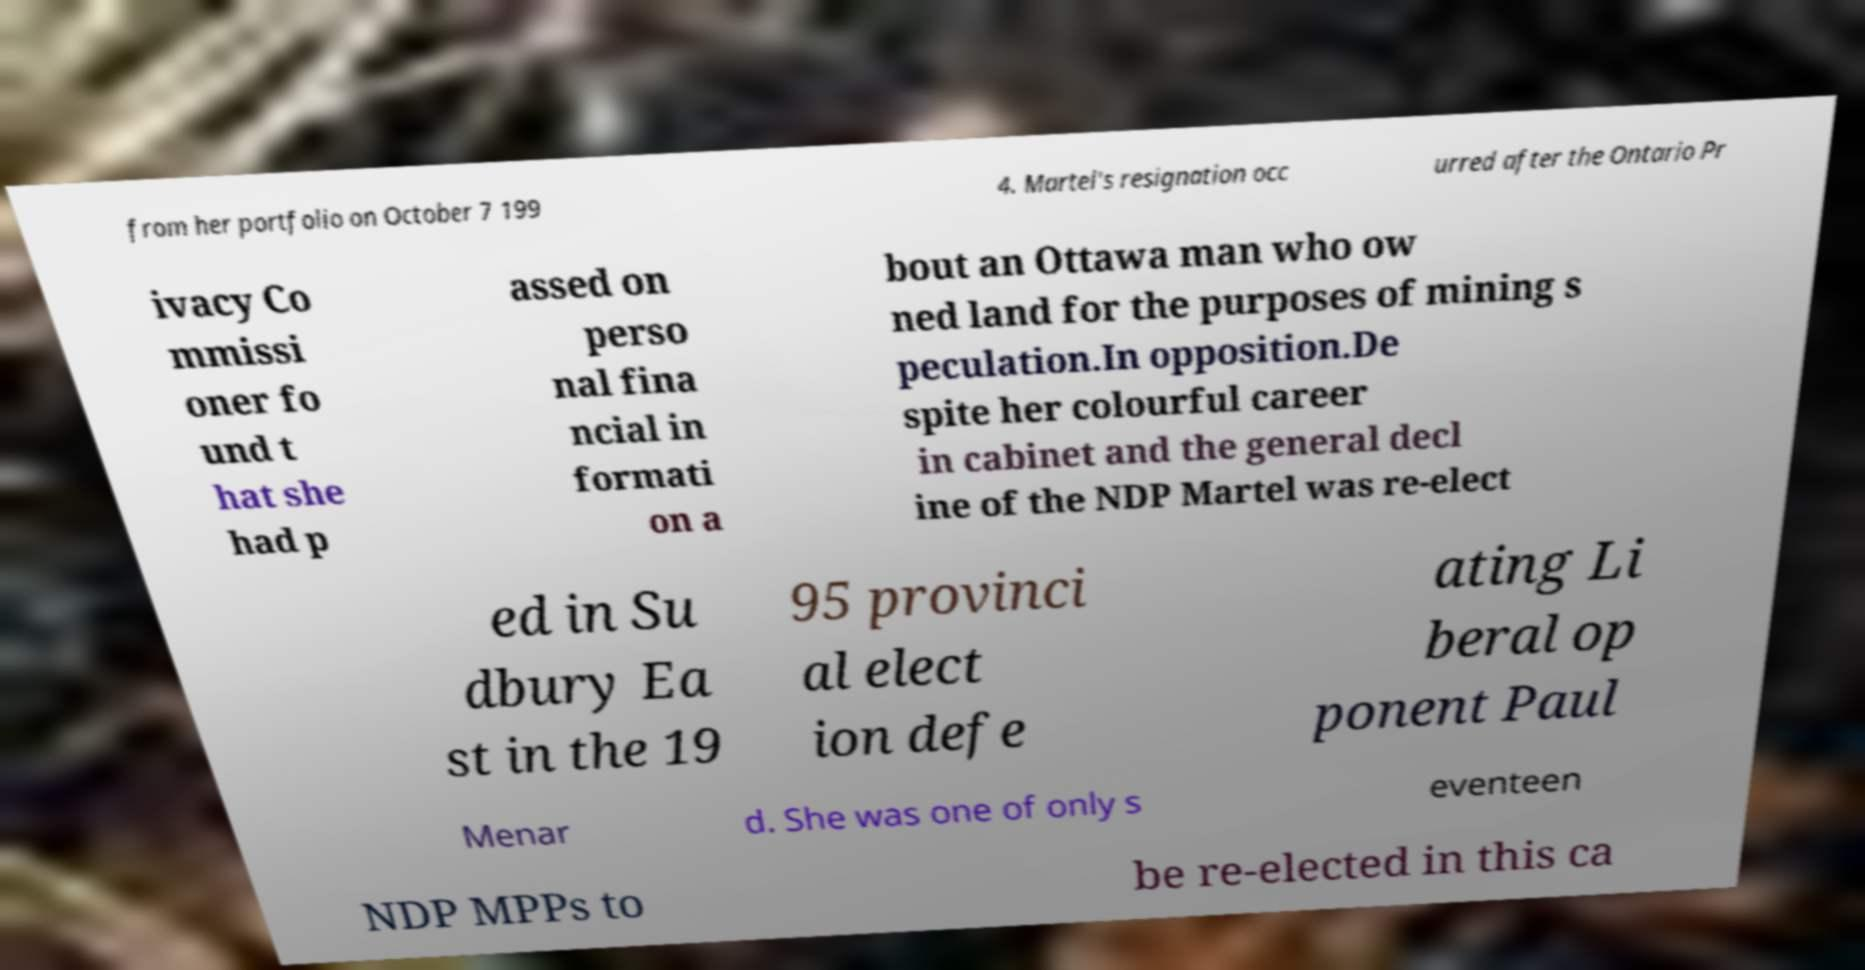Can you read and provide the text displayed in the image?This photo seems to have some interesting text. Can you extract and type it out for me? from her portfolio on October 7 199 4. Martel's resignation occ urred after the Ontario Pr ivacy Co mmissi oner fo und t hat she had p assed on perso nal fina ncial in formati on a bout an Ottawa man who ow ned land for the purposes of mining s peculation.In opposition.De spite her colourful career in cabinet and the general decl ine of the NDP Martel was re-elect ed in Su dbury Ea st in the 19 95 provinci al elect ion defe ating Li beral op ponent Paul Menar d. She was one of only s eventeen NDP MPPs to be re-elected in this ca 